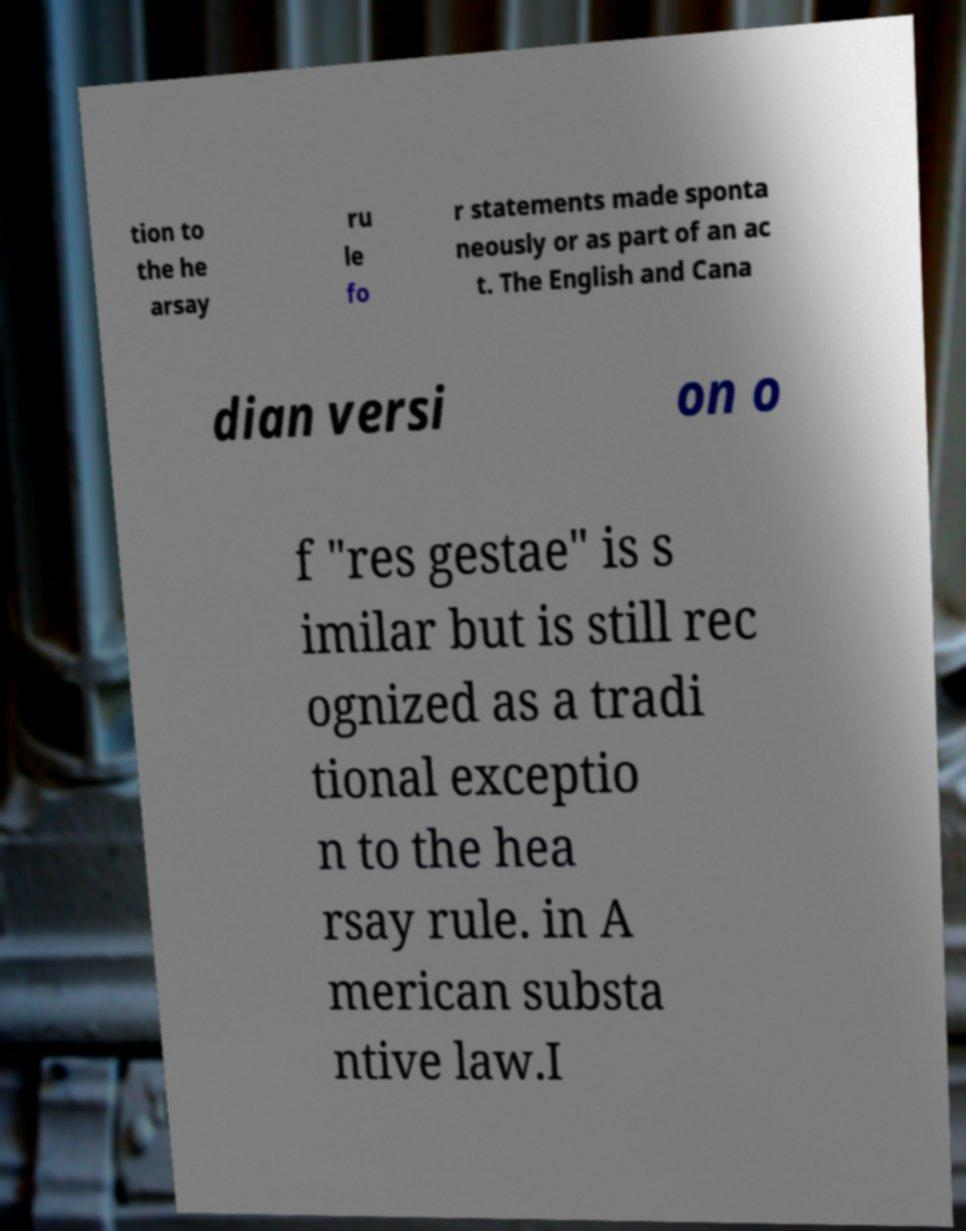What messages or text are displayed in this image? I need them in a readable, typed format. tion to the he arsay ru le fo r statements made sponta neously or as part of an ac t. The English and Cana dian versi on o f "res gestae" is s imilar but is still rec ognized as a tradi tional exceptio n to the hea rsay rule. in A merican substa ntive law.I 